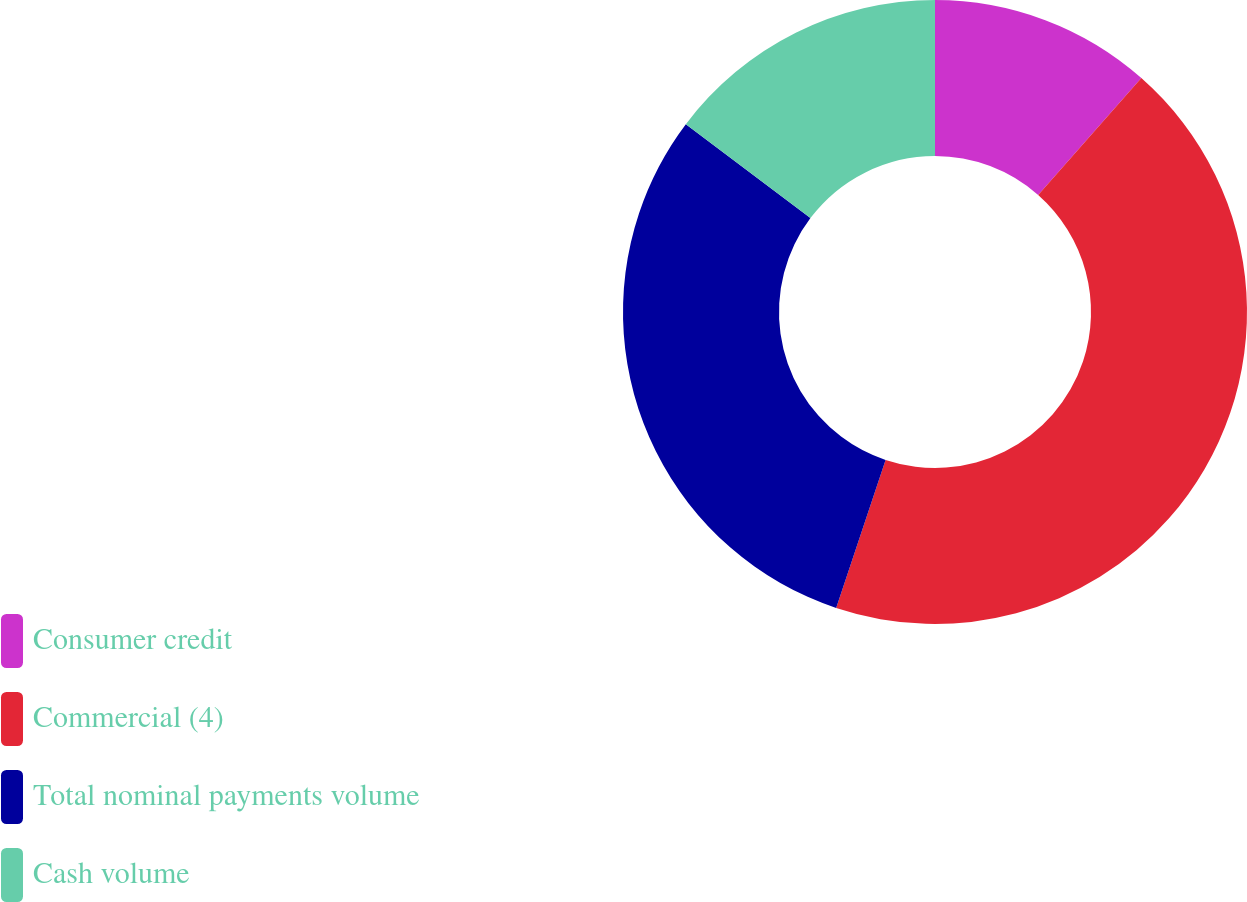Convert chart to OTSL. <chart><loc_0><loc_0><loc_500><loc_500><pie_chart><fcel>Consumer credit<fcel>Commercial (4)<fcel>Total nominal payments volume<fcel>Cash volume<nl><fcel>11.5%<fcel>43.63%<fcel>30.15%<fcel>14.72%<nl></chart> 